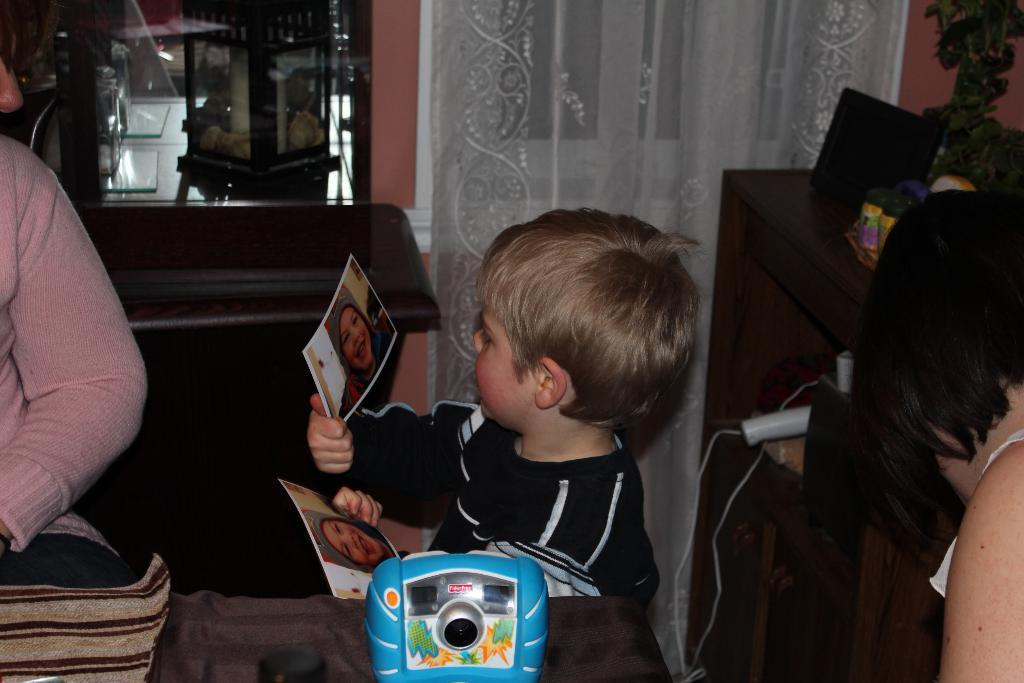What is the boy doing in the image? The boy is standing beside a table and holding photos in his hand. Who else is present in the image? There is another person standing nearby. What is on the table in the image? There is a table with many things on it. What type of apples can be seen in the image? There are no apples present in the image. How does the fog affect the visibility in the image? There is no fog present in the image, so it does not affect the visibility. 